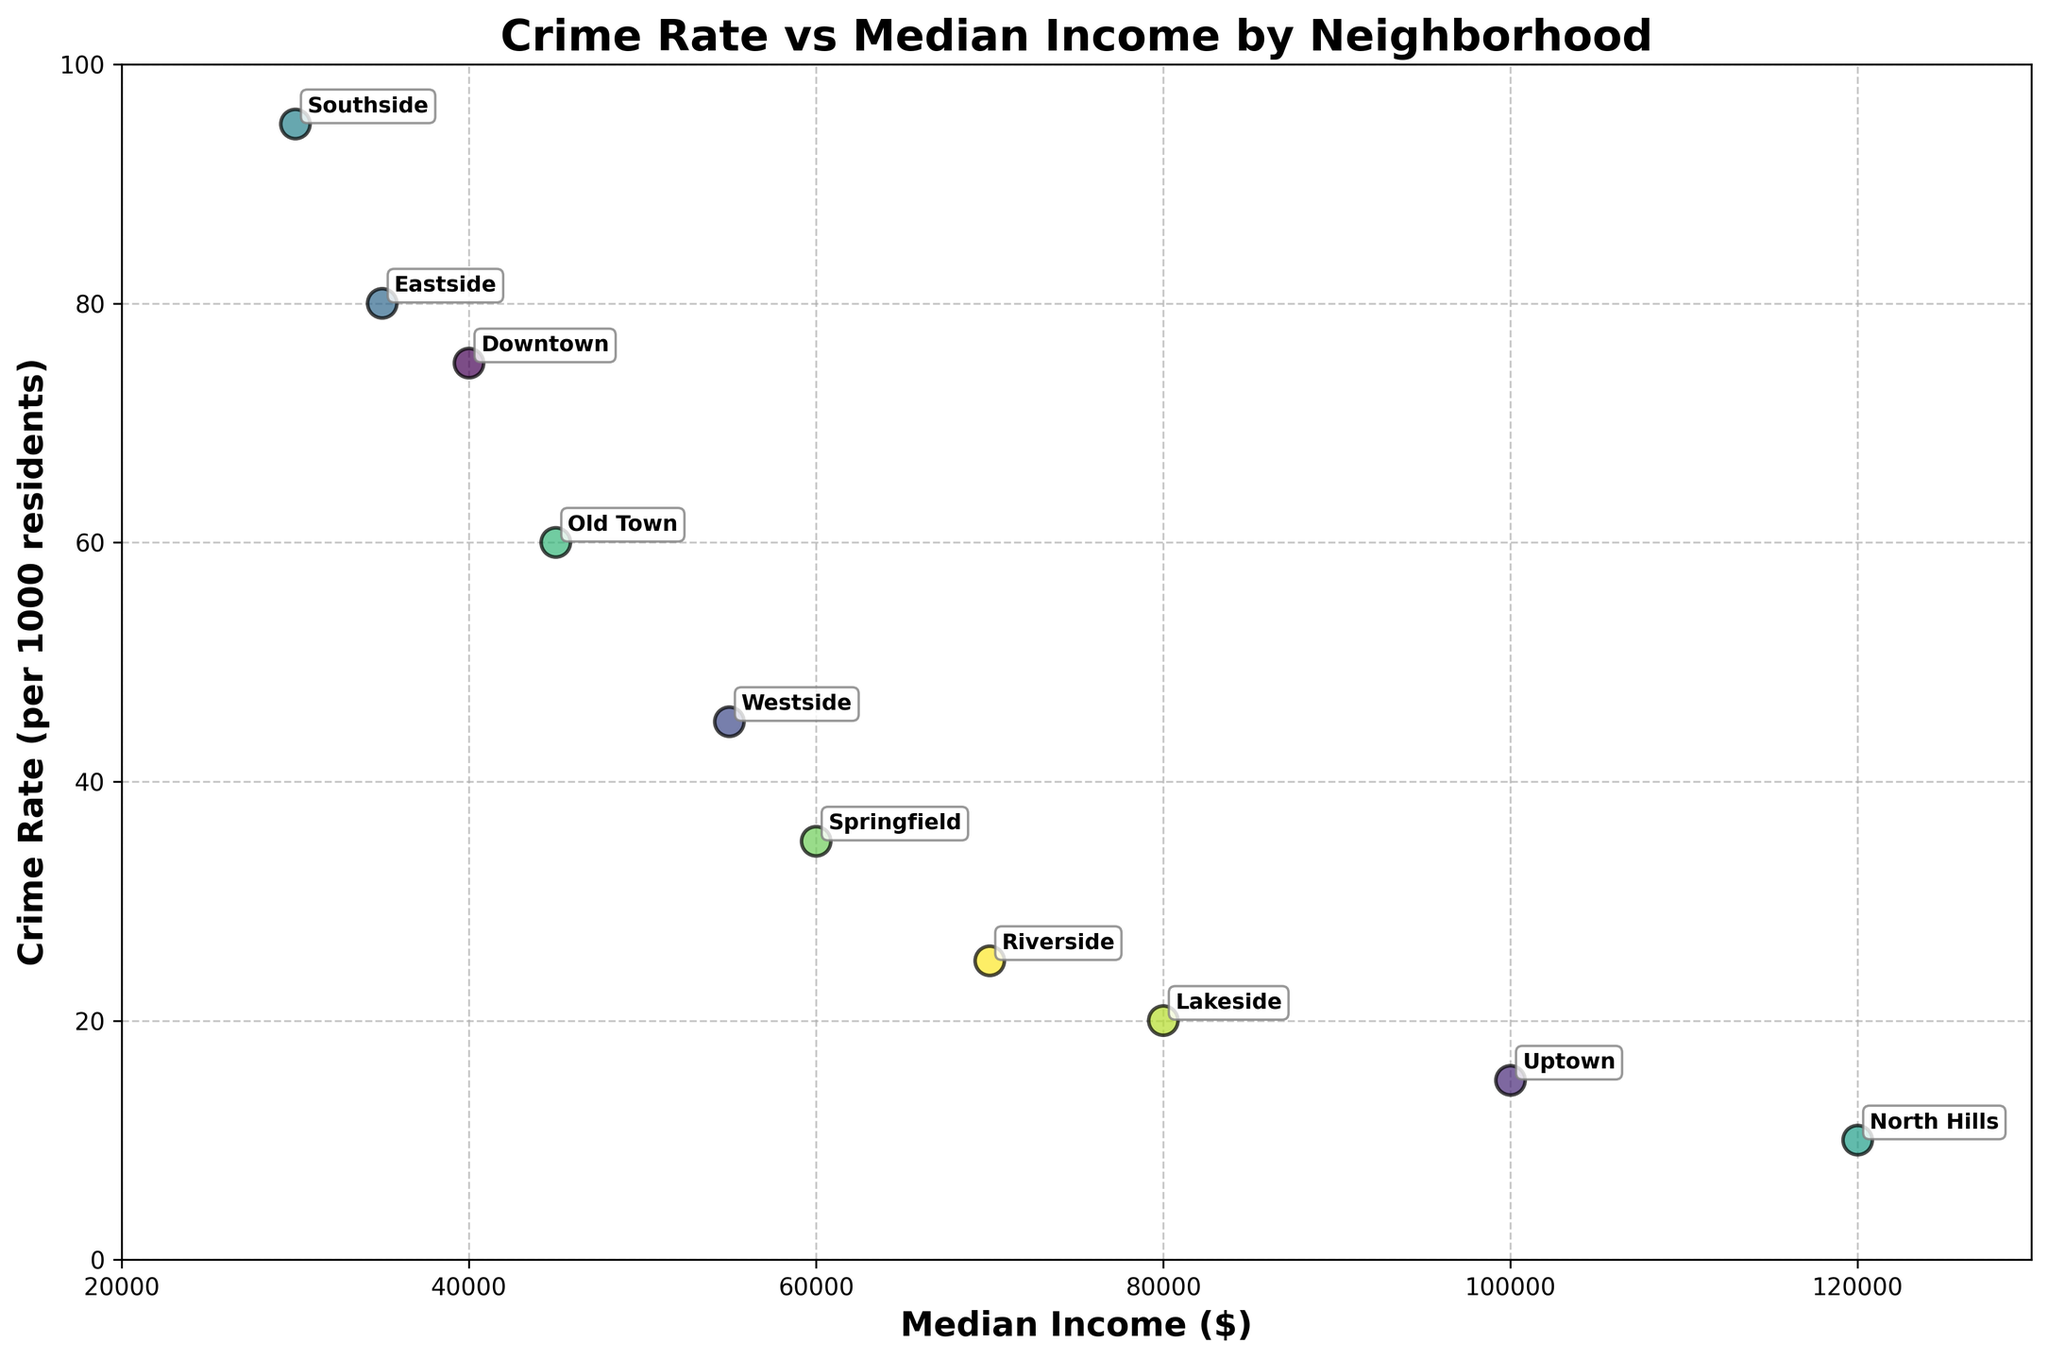What is the title of the plot? The title of the plot is usually found at the top center, above the graph. Here, it reads "Crime Rate vs Median Income by Neighborhood."
Answer: Crime Rate vs Median Income by Neighborhood How many neighborhoods are represented in the scatter plot? Count each unique data point labeled with a neighborhood name. There are 10 unique points labeled with neighborhood names.
Answer: 10 Which neighborhood has the highest crime rate? Look for the data point with the highest position on the y-axis, which is labeled. Southside has the highest crime rate at 95.
Answer: Southside Which neighborhood has the highest median income? Identify the data point farthest to the right on the x-axis, representing median income. North Hills has the highest median income at $120,000.
Answer: North Hills What is the median income of the neighborhood with the lowest crime rate? Find the point lowest on the y-axis representing crime rate, and check its corresponding median income on the x-axis. North Hills has the lowest crime rate and a median income of $120,000.
Answer: $120,000 Explain the relationship between median income and crime rate. Generally, observe the overall trend: as median income increases (moving right on the x-axis), crime rate tends to decrease (moving down on the y-axis). There is a negative correlation between median income and crime rate.
Answer: Negative correlation By how much does Springfield's crime rate differ from Eastside's? Subtract Eastside's crime rate (80) from Springfield's crime rate (35): 80 - 35. Springfield’s crime rate is 45 less than Eastside’s.
Answer: 45 less What’s the average median income of Downtown, Uptown, and Westside combined? Add the median incomes of the three neighborhoods: 40,000 (Downtown) + 100,000 (Uptown) + 55,000 (Westside) = 195,000. Then, divide by 3. 195,000 / 3 = 65,000.
Answer: $65,000 Which neighborhood lies closest to the point with median income of $60,000 and crime rate of 35? Locate the point nearest to the coordinates (60,000, 35). Springfield matches exactly with median income of $60,000 and crime rate of 35.
Answer: Springfield 